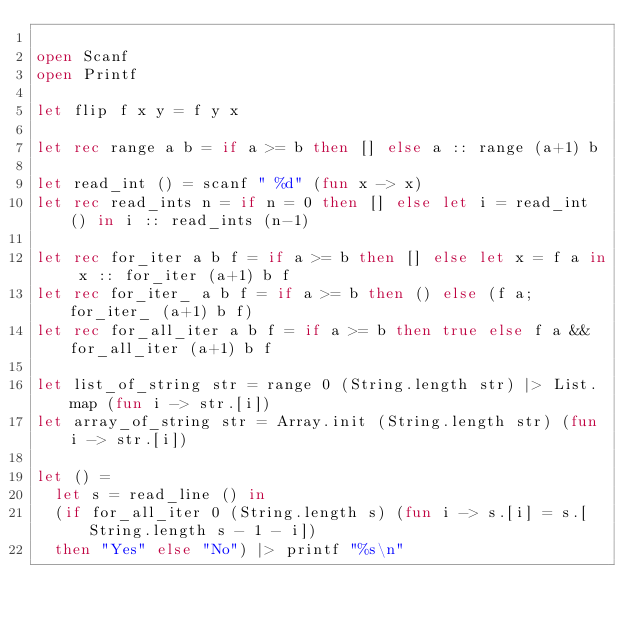<code> <loc_0><loc_0><loc_500><loc_500><_OCaml_>
open Scanf
open Printf

let flip f x y = f y x

let rec range a b = if a >= b then [] else a :: range (a+1) b

let read_int () = scanf " %d" (fun x -> x)
let rec read_ints n = if n = 0 then [] else let i = read_int () in i :: read_ints (n-1)

let rec for_iter a b f = if a >= b then [] else let x = f a in x :: for_iter (a+1) b f
let rec for_iter_ a b f = if a >= b then () else (f a; for_iter_ (a+1) b f)
let rec for_all_iter a b f = if a >= b then true else f a && for_all_iter (a+1) b f

let list_of_string str = range 0 (String.length str) |> List.map (fun i -> str.[i])
let array_of_string str = Array.init (String.length str) (fun i -> str.[i])

let () =
  let s = read_line () in
  (if for_all_iter 0 (String.length s) (fun i -> s.[i] = s.[String.length s - 1 - i])
  then "Yes" else "No") |> printf "%s\n"
</code> 